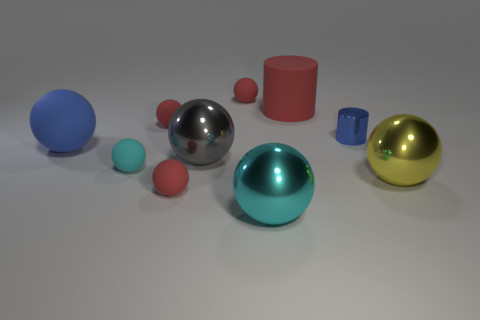How many rubber objects are blue balls or tiny red things?
Your response must be concise. 4. Does the large cylinder have the same color as the tiny shiny thing?
Offer a terse response. No. Are there any other things that are the same material as the yellow ball?
Offer a very short reply. Yes. How many things are either large green rubber cylinders or large metal balls behind the big cyan metallic object?
Make the answer very short. 2. There is a blue thing that is in front of the shiny cylinder; is it the same size as the blue cylinder?
Make the answer very short. No. How many other objects are there of the same shape as the large gray metallic object?
Your answer should be very brief. 7. How many brown objects are either small metal spheres or metal things?
Give a very brief answer. 0. Does the large object right of the rubber cylinder have the same color as the rubber cylinder?
Your answer should be very brief. No. What shape is the gray thing that is the same material as the big yellow ball?
Your answer should be compact. Sphere. There is a matte object that is both in front of the big red rubber cylinder and behind the blue rubber ball; what color is it?
Provide a short and direct response. Red. 